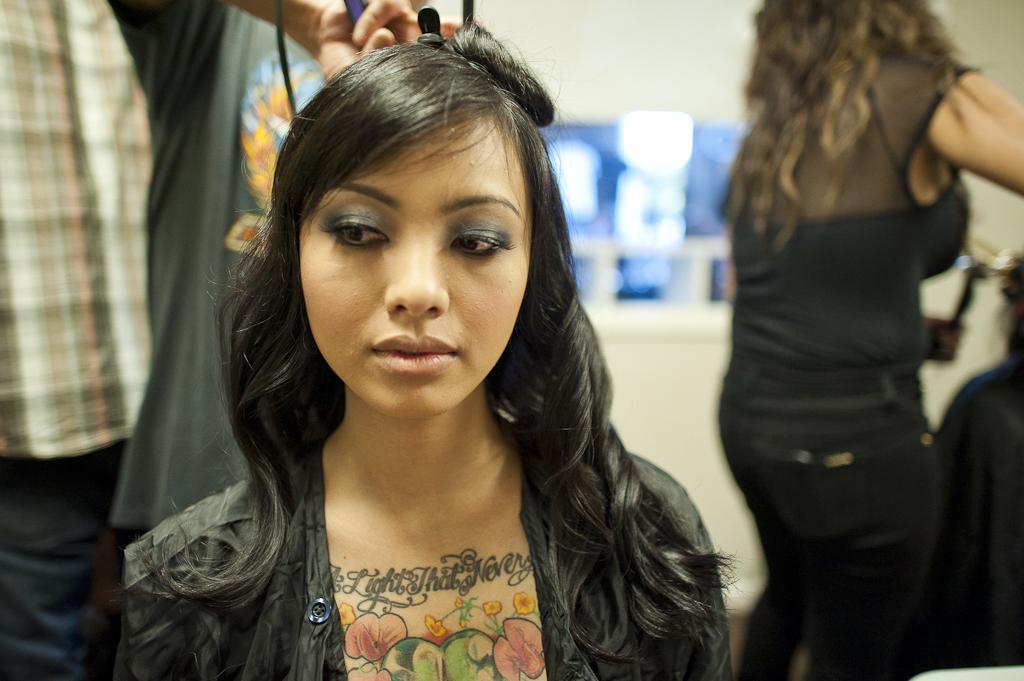Can you describe this image briefly? In this image I can see the group of people with different colored dressers. I can see one person holding an object and I can see the blurred background. 